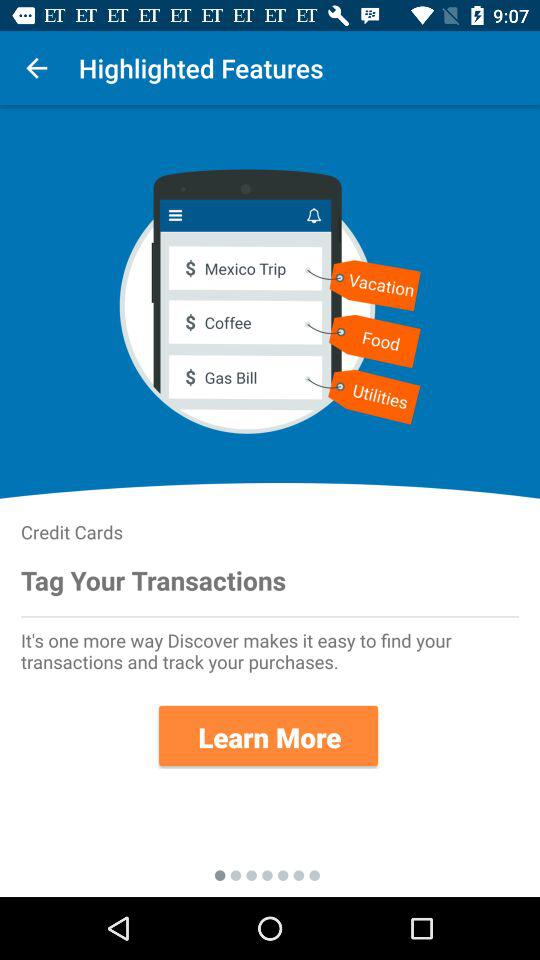Under which category does coffee fall? Coffee falls under "Food" category. 